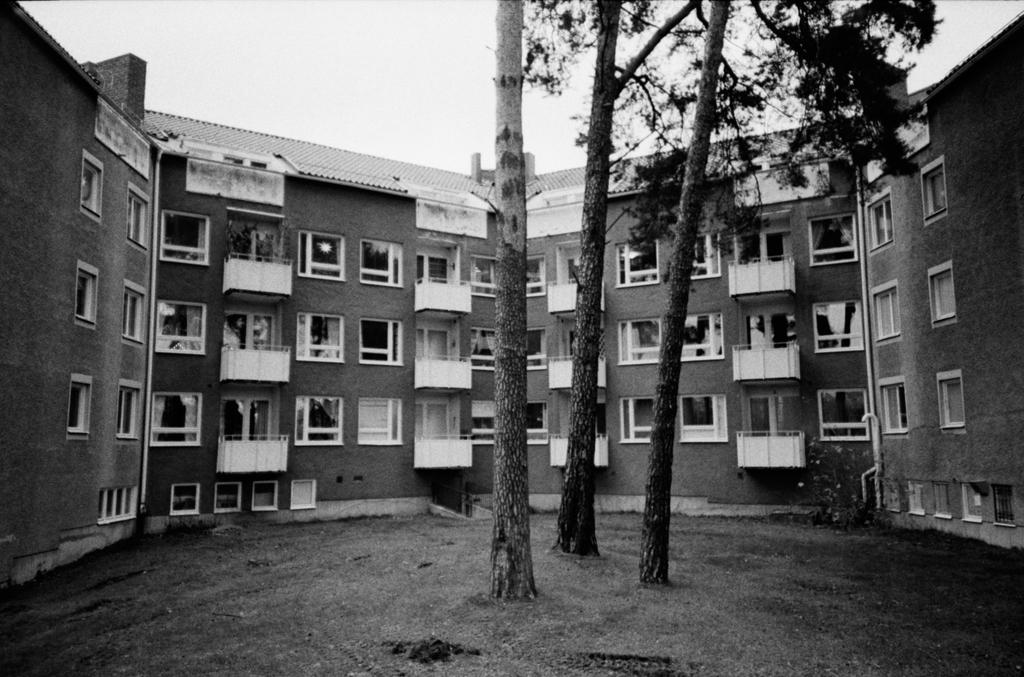How many trees are in the middle of the image? There are three trees in the middle of the image. Are there any trees in the background of the image? Yes, there is a tree in the background of the image. What color is the shirt on the tree in the image? There is no shirt present on any of the trees in the image. 